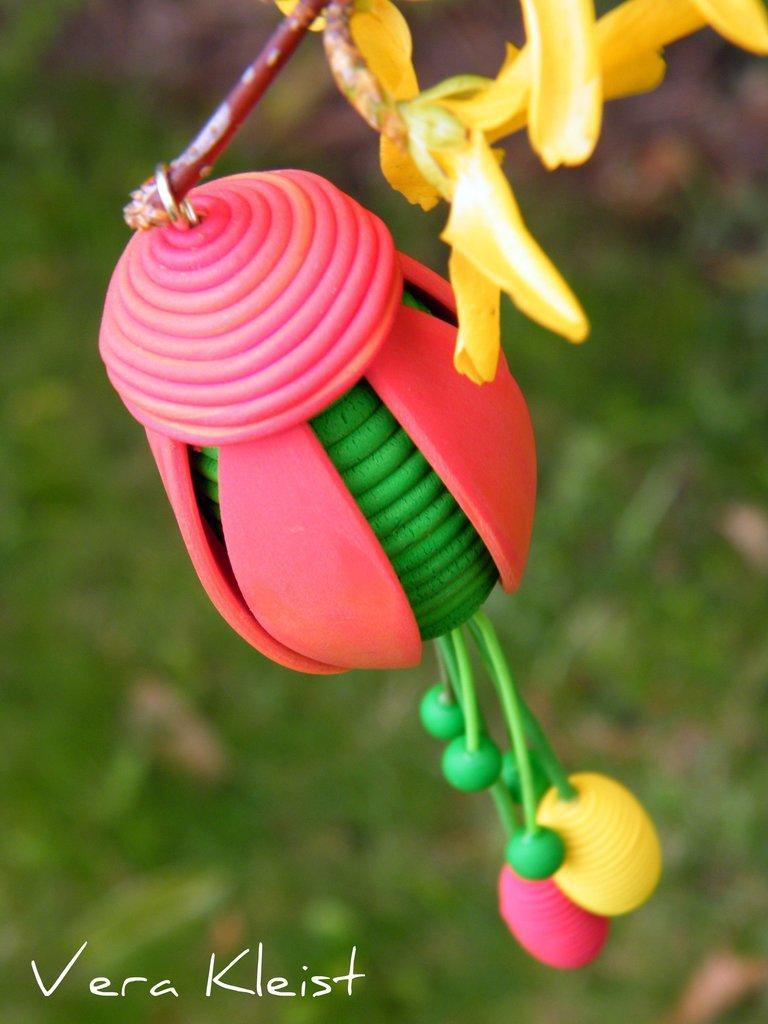How would you summarize this image in a sentence or two? In this image I can see some object in pink and green color, few flowers in yellow color and I can see the green color background. 